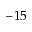<formula> <loc_0><loc_0><loc_500><loc_500>- 1 5</formula> 